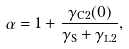Convert formula to latex. <formula><loc_0><loc_0><loc_500><loc_500>\alpha = 1 + \frac { \gamma _ { \mathrm C 2 } ( 0 ) } { \gamma _ { \mathrm S } + \gamma _ { \mathrm L 2 } } ,</formula> 